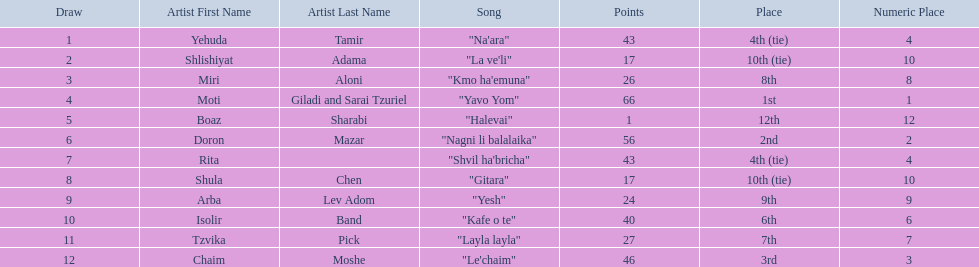Who are all of the artists? Yehuda Tamir, Shlishiyat Adama, Miri Aloni, Moti Giladi and Sarai Tzuriel, Boaz Sharabi, Doron Mazar, Rita, Shula Chen, Arba Lev Adom, Isolir Band, Tzvika Pick, Chaim Moshe. How many points did each score? 43, 17, 26, 66, 1, 56, 43, 17, 24, 40, 27, 46. And which artist had the least amount of points? Boaz Sharabi. 